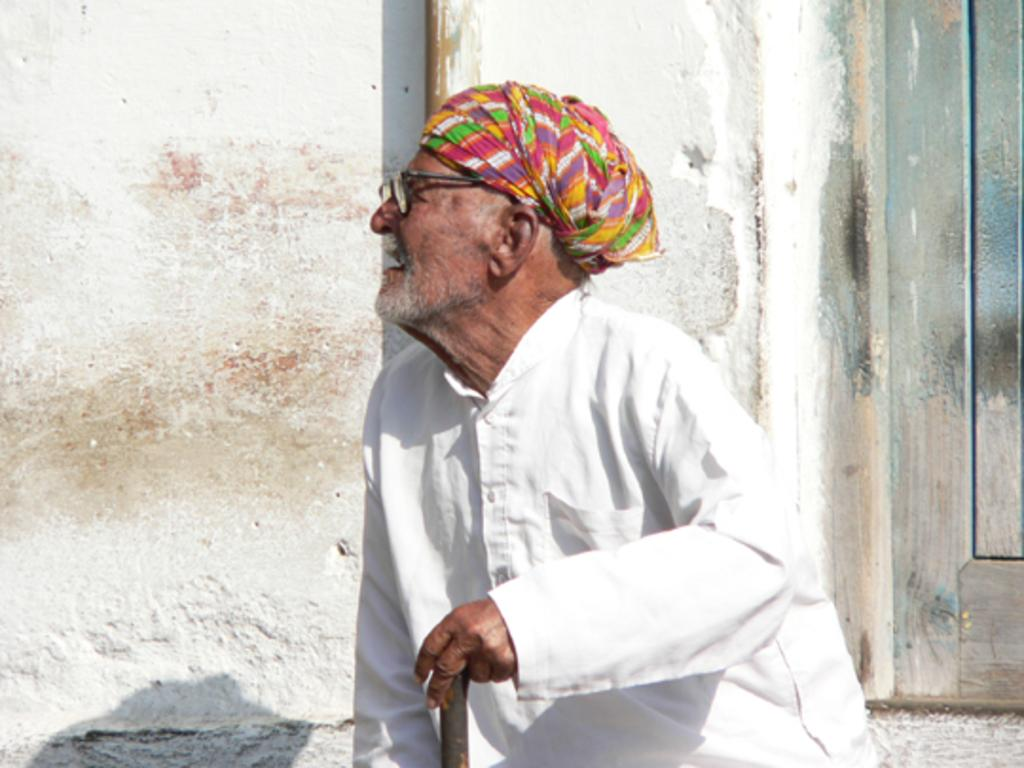What is the person in the image doing? The person is sitting in the image. What is the person holding in the image? The person is holding an object in the image. What can be seen in the background of the image? There is a pole, a door, and a wall in the background of the image. Where is the person brushing their teeth in the image? There is no indication in the image that the person is brushing their teeth, as no toothbrush or toothpaste is visible. 